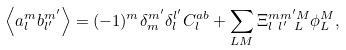<formula> <loc_0><loc_0><loc_500><loc_500>\left \langle a _ { l } ^ { m } b _ { l ^ { \prime } } ^ { m ^ { \prime } } \right \rangle = ( - 1 ) ^ { m } \delta _ { m } ^ { m ^ { \prime } } \delta _ { l } ^ { l ^ { \prime } } C _ { l } ^ { a b } + \sum _ { L M } { \Xi ^ { m m ^ { \prime } M } _ { l \ l ^ { \prime } \ L } \phi ^ { M } _ { L } } ,</formula> 